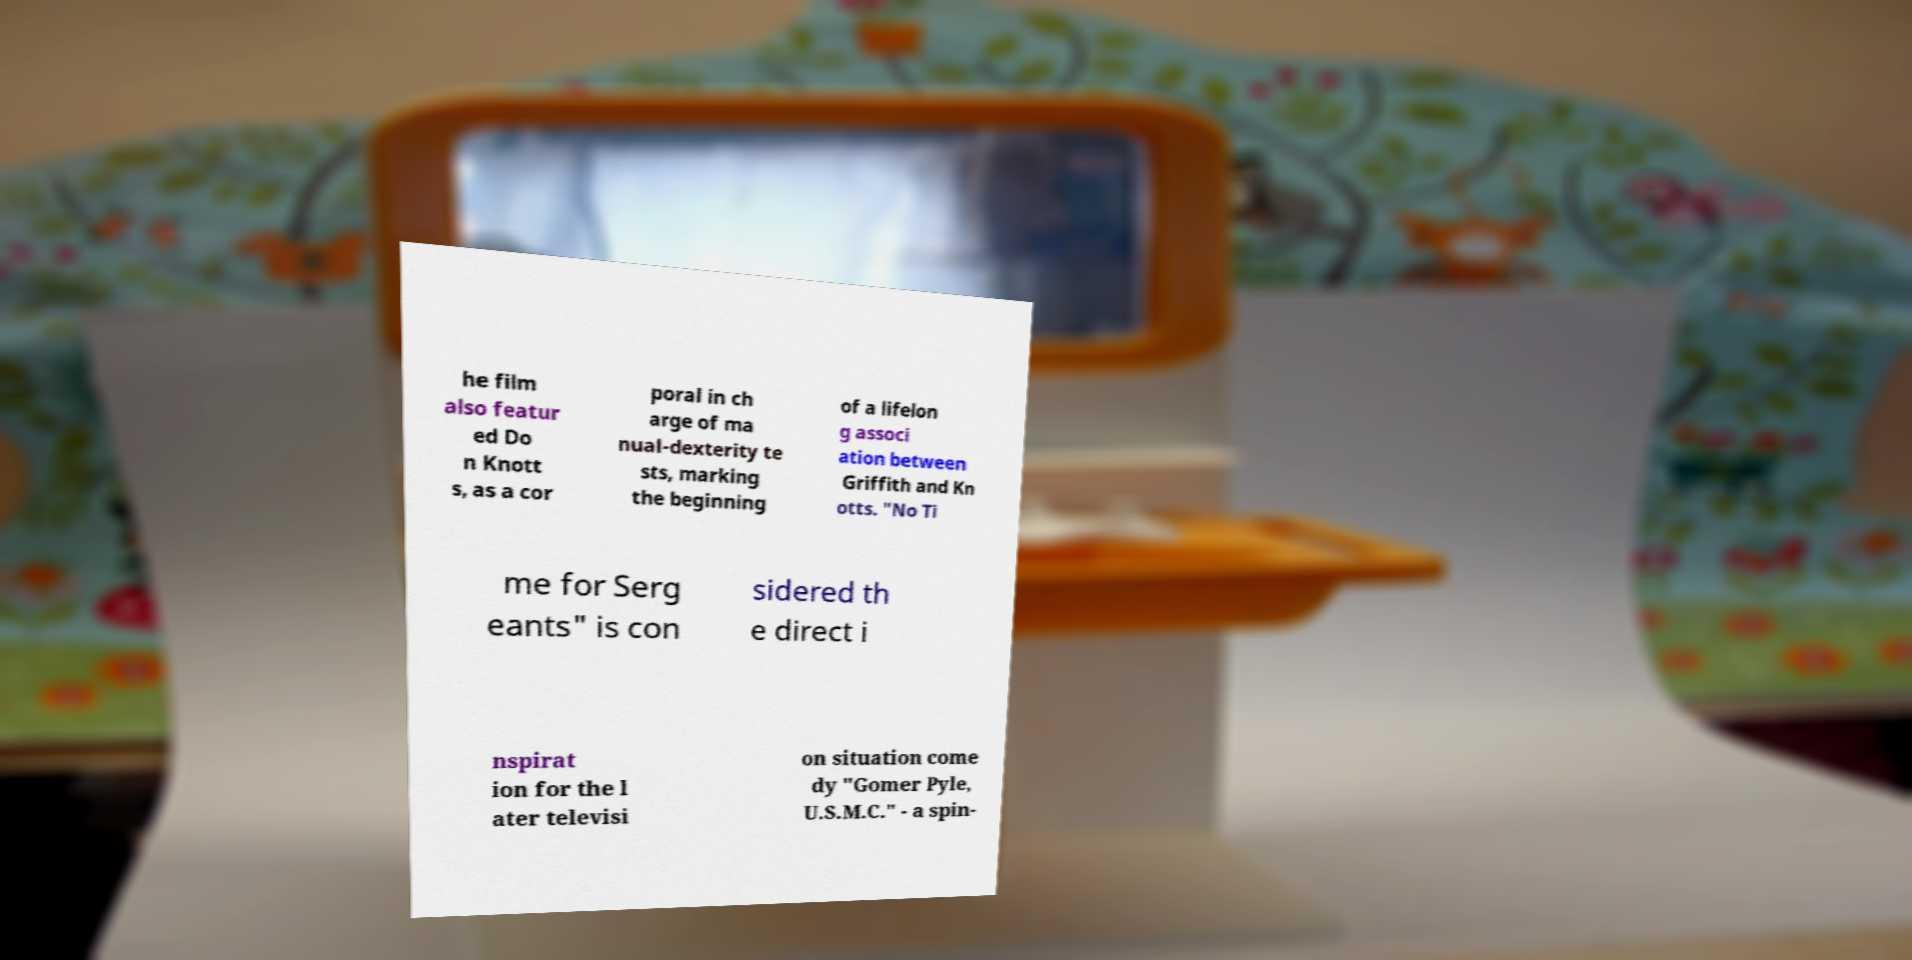Can you read and provide the text displayed in the image?This photo seems to have some interesting text. Can you extract and type it out for me? he film also featur ed Do n Knott s, as a cor poral in ch arge of ma nual-dexterity te sts, marking the beginning of a lifelon g associ ation between Griffith and Kn otts. "No Ti me for Serg eants" is con sidered th e direct i nspirat ion for the l ater televisi on situation come dy "Gomer Pyle, U.S.M.C." - a spin- 